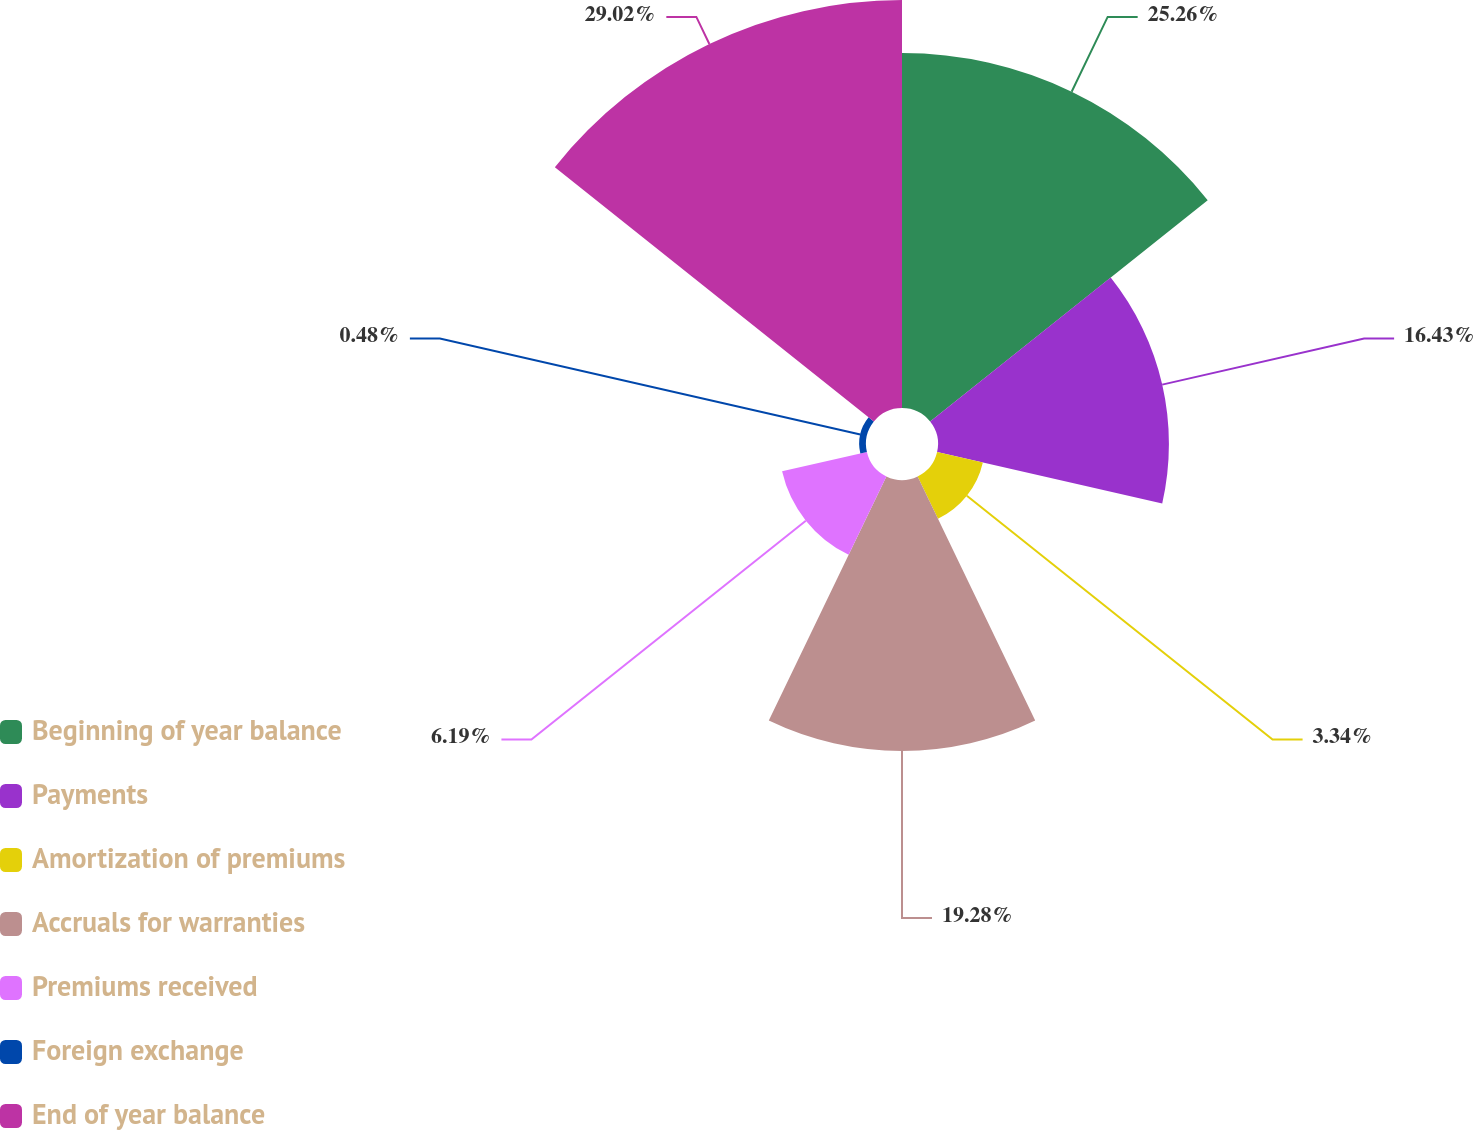Convert chart. <chart><loc_0><loc_0><loc_500><loc_500><pie_chart><fcel>Beginning of year balance<fcel>Payments<fcel>Amortization of premiums<fcel>Accruals for warranties<fcel>Premiums received<fcel>Foreign exchange<fcel>End of year balance<nl><fcel>25.26%<fcel>16.43%<fcel>3.34%<fcel>19.28%<fcel>6.19%<fcel>0.48%<fcel>29.03%<nl></chart> 